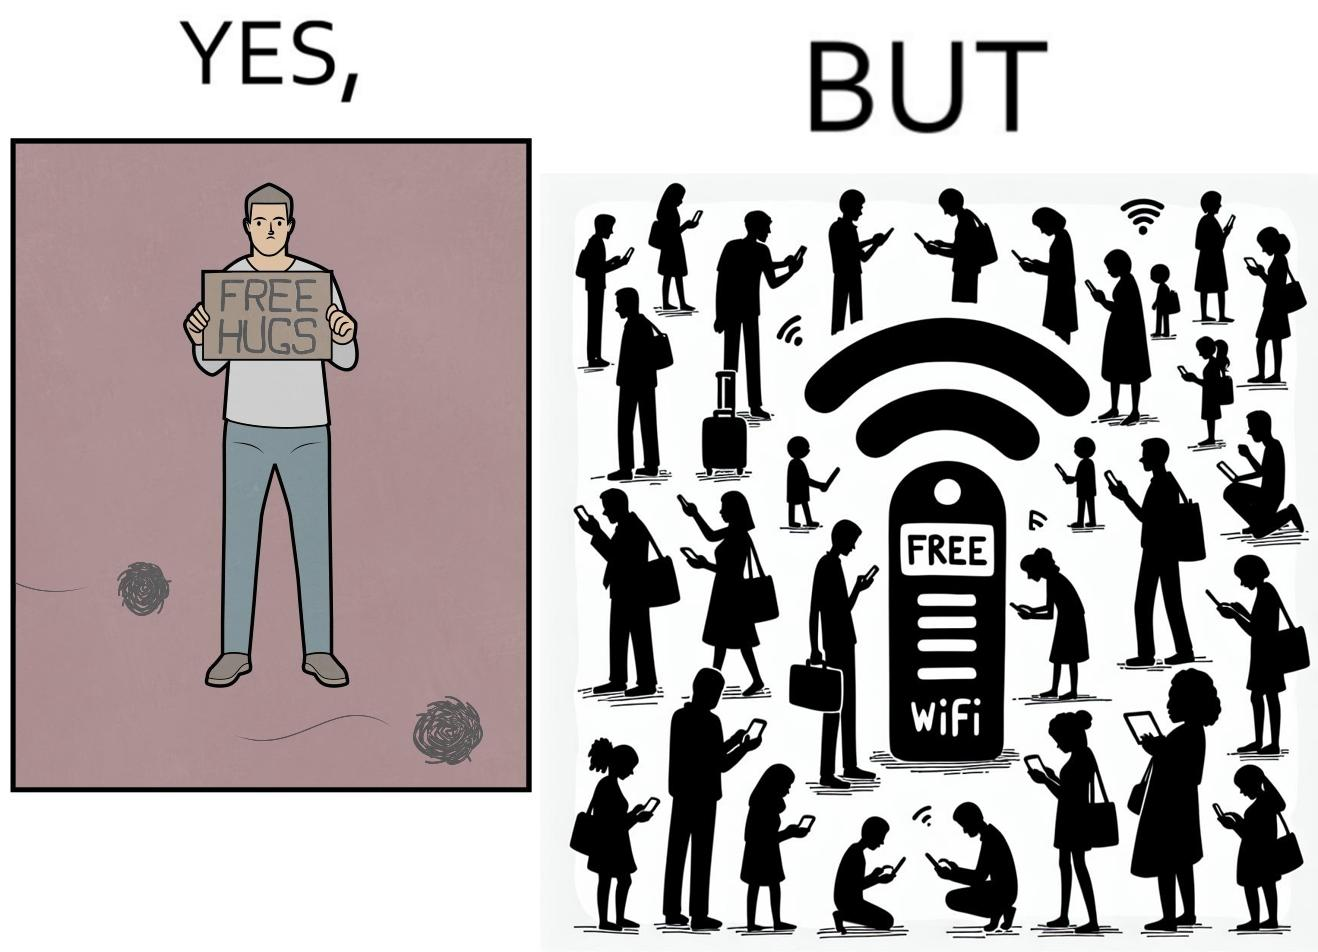What is shown in this image? This image is ironical, as a person holding up a "Free Hugs" sign is standing alone, while an inanimate Wi-fi Router giving "Free Wifi" is surrounded people trying to connect to it. This shows a growing lack of empathy in our society, while showing our increasing dependence on the digital devices in a virtual world. 